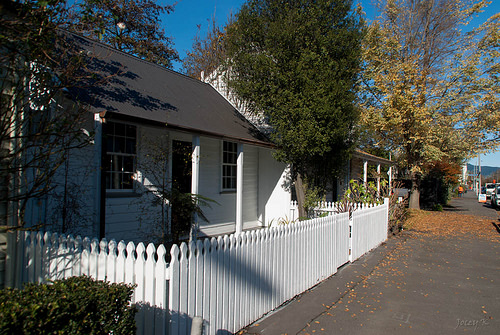<image>
Is the gate in front of the fence? No. The gate is not in front of the fence. The spatial positioning shows a different relationship between these objects. 